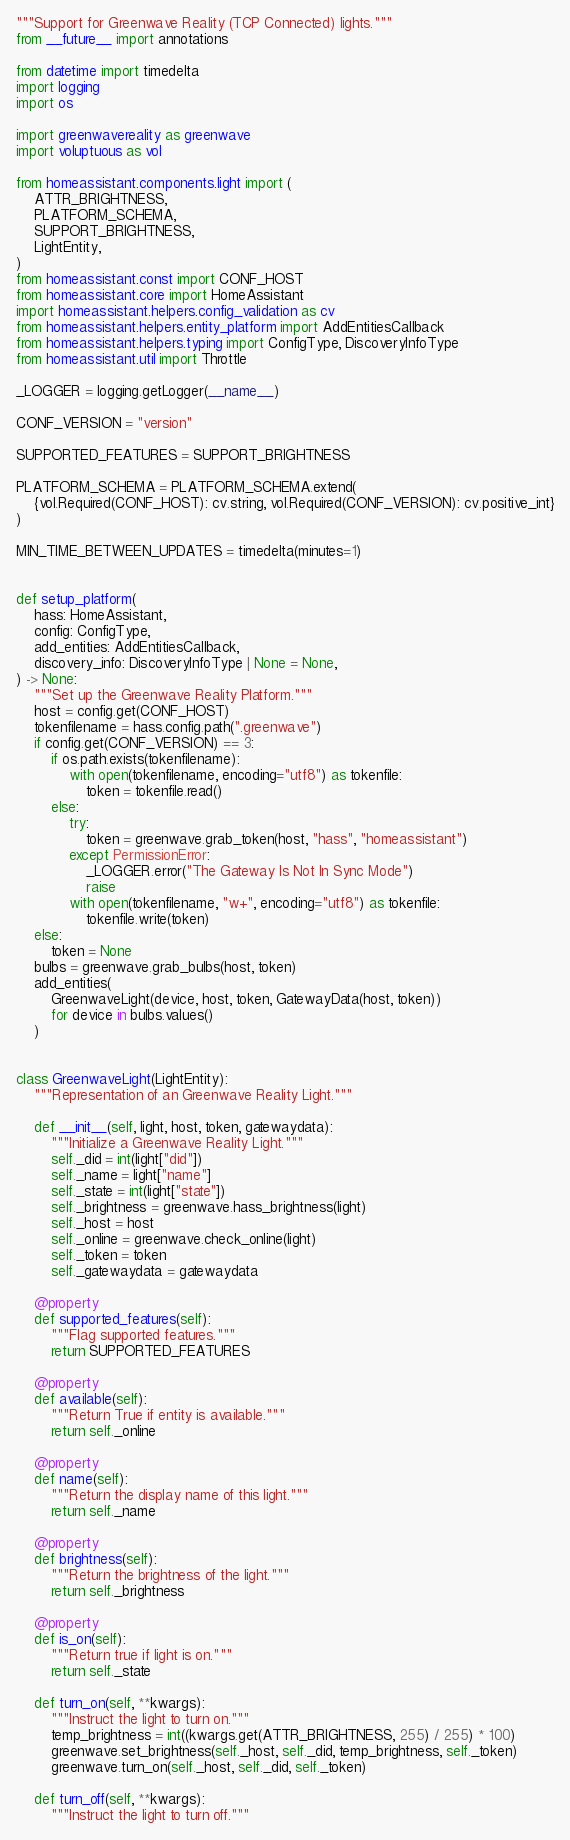<code> <loc_0><loc_0><loc_500><loc_500><_Python_>"""Support for Greenwave Reality (TCP Connected) lights."""
from __future__ import annotations

from datetime import timedelta
import logging
import os

import greenwavereality as greenwave
import voluptuous as vol

from homeassistant.components.light import (
    ATTR_BRIGHTNESS,
    PLATFORM_SCHEMA,
    SUPPORT_BRIGHTNESS,
    LightEntity,
)
from homeassistant.const import CONF_HOST
from homeassistant.core import HomeAssistant
import homeassistant.helpers.config_validation as cv
from homeassistant.helpers.entity_platform import AddEntitiesCallback
from homeassistant.helpers.typing import ConfigType, DiscoveryInfoType
from homeassistant.util import Throttle

_LOGGER = logging.getLogger(__name__)

CONF_VERSION = "version"

SUPPORTED_FEATURES = SUPPORT_BRIGHTNESS

PLATFORM_SCHEMA = PLATFORM_SCHEMA.extend(
    {vol.Required(CONF_HOST): cv.string, vol.Required(CONF_VERSION): cv.positive_int}
)

MIN_TIME_BETWEEN_UPDATES = timedelta(minutes=1)


def setup_platform(
    hass: HomeAssistant,
    config: ConfigType,
    add_entities: AddEntitiesCallback,
    discovery_info: DiscoveryInfoType | None = None,
) -> None:
    """Set up the Greenwave Reality Platform."""
    host = config.get(CONF_HOST)
    tokenfilename = hass.config.path(".greenwave")
    if config.get(CONF_VERSION) == 3:
        if os.path.exists(tokenfilename):
            with open(tokenfilename, encoding="utf8") as tokenfile:
                token = tokenfile.read()
        else:
            try:
                token = greenwave.grab_token(host, "hass", "homeassistant")
            except PermissionError:
                _LOGGER.error("The Gateway Is Not In Sync Mode")
                raise
            with open(tokenfilename, "w+", encoding="utf8") as tokenfile:
                tokenfile.write(token)
    else:
        token = None
    bulbs = greenwave.grab_bulbs(host, token)
    add_entities(
        GreenwaveLight(device, host, token, GatewayData(host, token))
        for device in bulbs.values()
    )


class GreenwaveLight(LightEntity):
    """Representation of an Greenwave Reality Light."""

    def __init__(self, light, host, token, gatewaydata):
        """Initialize a Greenwave Reality Light."""
        self._did = int(light["did"])
        self._name = light["name"]
        self._state = int(light["state"])
        self._brightness = greenwave.hass_brightness(light)
        self._host = host
        self._online = greenwave.check_online(light)
        self._token = token
        self._gatewaydata = gatewaydata

    @property
    def supported_features(self):
        """Flag supported features."""
        return SUPPORTED_FEATURES

    @property
    def available(self):
        """Return True if entity is available."""
        return self._online

    @property
    def name(self):
        """Return the display name of this light."""
        return self._name

    @property
    def brightness(self):
        """Return the brightness of the light."""
        return self._brightness

    @property
    def is_on(self):
        """Return true if light is on."""
        return self._state

    def turn_on(self, **kwargs):
        """Instruct the light to turn on."""
        temp_brightness = int((kwargs.get(ATTR_BRIGHTNESS, 255) / 255) * 100)
        greenwave.set_brightness(self._host, self._did, temp_brightness, self._token)
        greenwave.turn_on(self._host, self._did, self._token)

    def turn_off(self, **kwargs):
        """Instruct the light to turn off."""</code> 